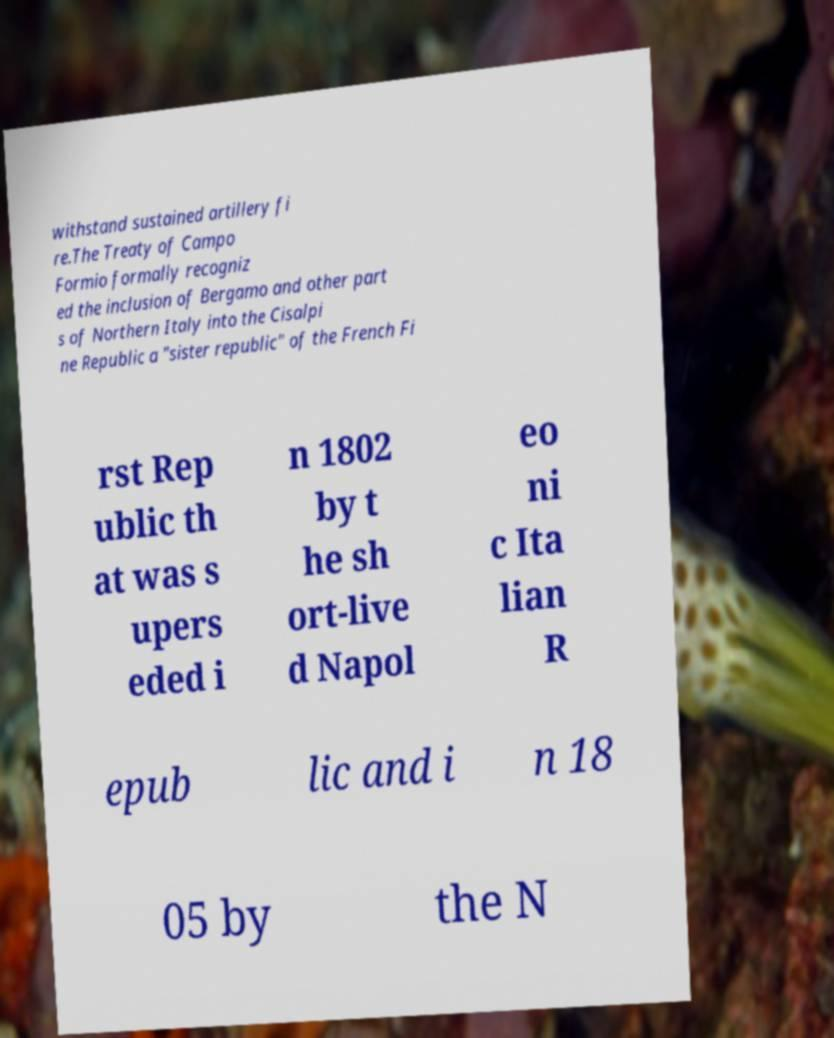Please identify and transcribe the text found in this image. withstand sustained artillery fi re.The Treaty of Campo Formio formally recogniz ed the inclusion of Bergamo and other part s of Northern Italy into the Cisalpi ne Republic a "sister republic" of the French Fi rst Rep ublic th at was s upers eded i n 1802 by t he sh ort-live d Napol eo ni c Ita lian R epub lic and i n 18 05 by the N 